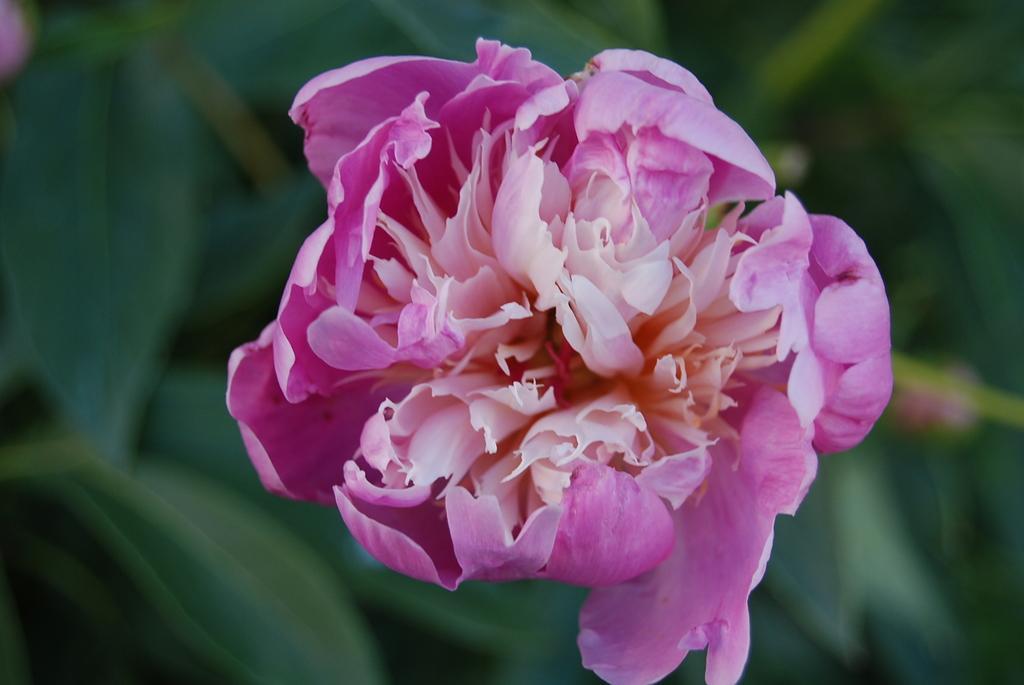Can you describe this image briefly? In this image I can see the flower which is in pink and cream color. In the background I can see the plants but it is blurry. 